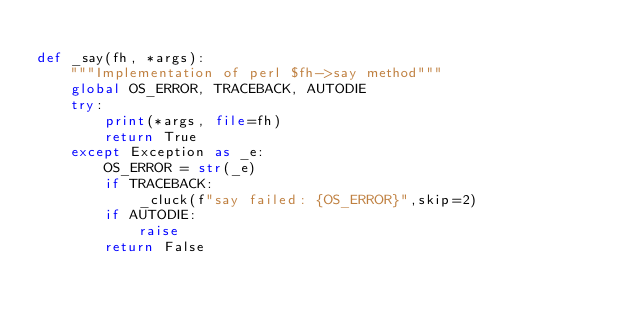Convert code to text. <code><loc_0><loc_0><loc_500><loc_500><_Python_>
def _say(fh, *args):
    """Implementation of perl $fh->say method"""
    global OS_ERROR, TRACEBACK, AUTODIE
    try:
        print(*args, file=fh)
        return True
    except Exception as _e:
        OS_ERROR = str(_e)
        if TRACEBACK:
            _cluck(f"say failed: {OS_ERROR}",skip=2)
        if AUTODIE:
            raise
        return False

</code> 